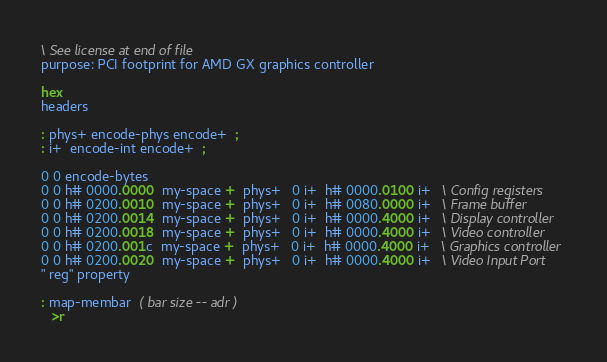Convert code to text. <code><loc_0><loc_0><loc_500><loc_500><_Forth_>\ See license at end of file
purpose: PCI footprint for AMD GX graphics controller

hex
headers

: phys+ encode-phys encode+  ;
: i+  encode-int encode+  ;

0 0 encode-bytes
0 0 h# 0000.0000  my-space +  phys+   0 i+  h# 0000.0100 i+   \ Config registers
0 0 h# 0200.0010  my-space +  phys+   0 i+  h# 0080.0000 i+   \ Frame buffer
0 0 h# 0200.0014  my-space +  phys+   0 i+  h# 0000.4000 i+   \ Display controller
0 0 h# 0200.0018  my-space +  phys+   0 i+  h# 0000.4000 i+   \ Video controller
0 0 h# 0200.001c  my-space +  phys+   0 i+  h# 0000.4000 i+   \ Graphics controller
0 0 h# 0200.0020  my-space +  phys+   0 i+  h# 0000.4000 i+   \ Video Input Port
" reg" property

: map-membar  ( bar size -- adr )
   >r</code> 